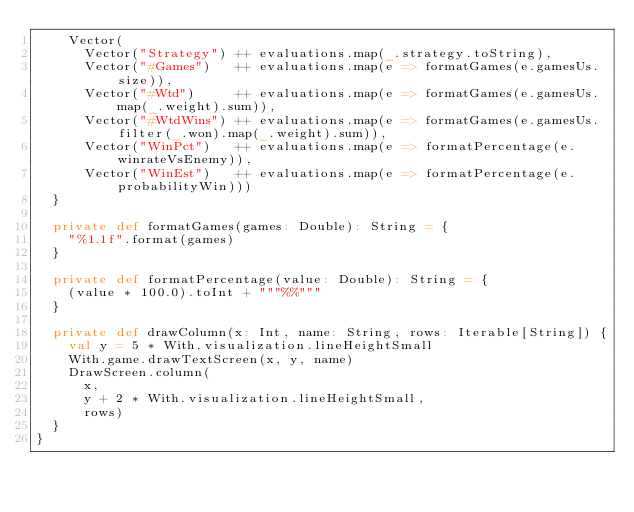Convert code to text. <code><loc_0><loc_0><loc_500><loc_500><_Scala_>    Vector(
      Vector("Strategy") ++ evaluations.map(_.strategy.toString),
      Vector("#Games")   ++ evaluations.map(e => formatGames(e.gamesUs.size)),
      Vector("#Wtd")     ++ evaluations.map(e => formatGames(e.gamesUs.map(_.weight).sum)),
      Vector("#WtdWins") ++ evaluations.map(e => formatGames(e.gamesUs.filter(_.won).map(_.weight).sum)),
      Vector("WinPct")   ++ evaluations.map(e => formatPercentage(e.winrateVsEnemy)),
      Vector("WinEst")   ++ evaluations.map(e => formatPercentage(e.probabilityWin)))
  }
  
  private def formatGames(games: Double): String = {
    "%1.1f".format(games)
  }
  
  private def formatPercentage(value: Double): String = {
    (value * 100.0).toInt + """%%"""
  }
  
  private def drawColumn(x: Int, name: String, rows: Iterable[String]) {
    val y = 5 * With.visualization.lineHeightSmall
    With.game.drawTextScreen(x, y, name)
    DrawScreen.column(
      x,
      y + 2 * With.visualization.lineHeightSmall,
      rows)
  }
}
</code> 